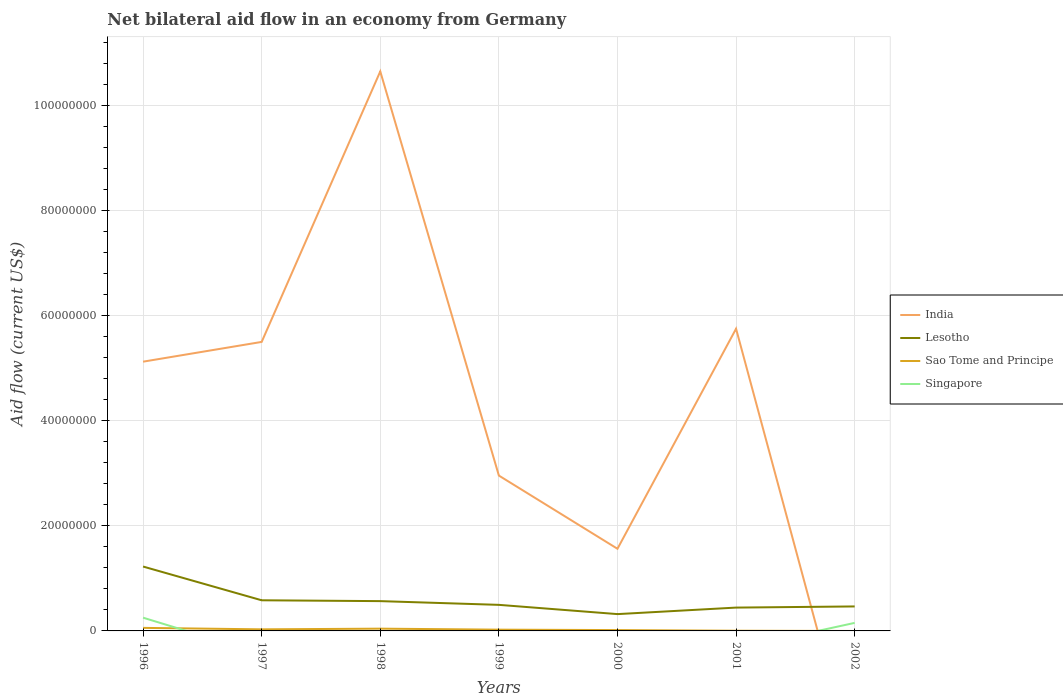Across all years, what is the maximum net bilateral aid flow in Lesotho?
Ensure brevity in your answer.  3.20e+06. What is the difference between the highest and the second highest net bilateral aid flow in Sao Tome and Principe?
Provide a short and direct response. 5.80e+05. Is the net bilateral aid flow in India strictly greater than the net bilateral aid flow in Sao Tome and Principe over the years?
Give a very brief answer. No. How many lines are there?
Offer a very short reply. 4. How many years are there in the graph?
Offer a very short reply. 7. Are the values on the major ticks of Y-axis written in scientific E-notation?
Give a very brief answer. No. Does the graph contain any zero values?
Give a very brief answer. Yes. Does the graph contain grids?
Your response must be concise. Yes. How many legend labels are there?
Offer a terse response. 4. What is the title of the graph?
Offer a terse response. Net bilateral aid flow in an economy from Germany. Does "Czech Republic" appear as one of the legend labels in the graph?
Provide a short and direct response. No. What is the label or title of the X-axis?
Provide a succinct answer. Years. What is the label or title of the Y-axis?
Ensure brevity in your answer.  Aid flow (current US$). What is the Aid flow (current US$) in India in 1996?
Your response must be concise. 5.12e+07. What is the Aid flow (current US$) in Lesotho in 1996?
Offer a terse response. 1.22e+07. What is the Aid flow (current US$) in Sao Tome and Principe in 1996?
Ensure brevity in your answer.  5.80e+05. What is the Aid flow (current US$) in Singapore in 1996?
Your answer should be compact. 2.52e+06. What is the Aid flow (current US$) of India in 1997?
Make the answer very short. 5.50e+07. What is the Aid flow (current US$) of Lesotho in 1997?
Give a very brief answer. 5.83e+06. What is the Aid flow (current US$) of India in 1998?
Your answer should be very brief. 1.06e+08. What is the Aid flow (current US$) of Lesotho in 1998?
Provide a succinct answer. 5.67e+06. What is the Aid flow (current US$) of Sao Tome and Principe in 1998?
Offer a terse response. 4.30e+05. What is the Aid flow (current US$) in Singapore in 1998?
Your answer should be very brief. 0. What is the Aid flow (current US$) of India in 1999?
Your response must be concise. 2.96e+07. What is the Aid flow (current US$) in Lesotho in 1999?
Your answer should be compact. 4.96e+06. What is the Aid flow (current US$) in Sao Tome and Principe in 1999?
Your answer should be very brief. 2.40e+05. What is the Aid flow (current US$) in Singapore in 1999?
Provide a short and direct response. 0. What is the Aid flow (current US$) of India in 2000?
Your answer should be very brief. 1.56e+07. What is the Aid flow (current US$) in Lesotho in 2000?
Offer a very short reply. 3.20e+06. What is the Aid flow (current US$) of Sao Tome and Principe in 2000?
Offer a very short reply. 1.60e+05. What is the Aid flow (current US$) in Singapore in 2000?
Provide a short and direct response. 0. What is the Aid flow (current US$) of India in 2001?
Offer a terse response. 5.75e+07. What is the Aid flow (current US$) of Lesotho in 2001?
Make the answer very short. 4.44e+06. What is the Aid flow (current US$) in Singapore in 2001?
Offer a very short reply. 0. What is the Aid flow (current US$) in India in 2002?
Make the answer very short. 0. What is the Aid flow (current US$) of Lesotho in 2002?
Offer a terse response. 4.66e+06. What is the Aid flow (current US$) of Singapore in 2002?
Ensure brevity in your answer.  1.53e+06. Across all years, what is the maximum Aid flow (current US$) in India?
Your answer should be compact. 1.06e+08. Across all years, what is the maximum Aid flow (current US$) in Lesotho?
Ensure brevity in your answer.  1.22e+07. Across all years, what is the maximum Aid flow (current US$) of Sao Tome and Principe?
Make the answer very short. 5.80e+05. Across all years, what is the maximum Aid flow (current US$) of Singapore?
Offer a terse response. 2.52e+06. Across all years, what is the minimum Aid flow (current US$) in India?
Provide a short and direct response. 0. Across all years, what is the minimum Aid flow (current US$) of Lesotho?
Provide a short and direct response. 3.20e+06. Across all years, what is the minimum Aid flow (current US$) in Sao Tome and Principe?
Keep it short and to the point. 0. Across all years, what is the minimum Aid flow (current US$) of Singapore?
Keep it short and to the point. 0. What is the total Aid flow (current US$) in India in the graph?
Offer a terse response. 3.15e+08. What is the total Aid flow (current US$) of Lesotho in the graph?
Give a very brief answer. 4.10e+07. What is the total Aid flow (current US$) of Sao Tome and Principe in the graph?
Your answer should be very brief. 1.75e+06. What is the total Aid flow (current US$) of Singapore in the graph?
Keep it short and to the point. 4.05e+06. What is the difference between the Aid flow (current US$) in India in 1996 and that in 1997?
Give a very brief answer. -3.76e+06. What is the difference between the Aid flow (current US$) of Lesotho in 1996 and that in 1997?
Your answer should be compact. 6.42e+06. What is the difference between the Aid flow (current US$) in India in 1996 and that in 1998?
Give a very brief answer. -5.52e+07. What is the difference between the Aid flow (current US$) of Lesotho in 1996 and that in 1998?
Your answer should be compact. 6.58e+06. What is the difference between the Aid flow (current US$) in Sao Tome and Principe in 1996 and that in 1998?
Your response must be concise. 1.50e+05. What is the difference between the Aid flow (current US$) in India in 1996 and that in 1999?
Provide a succinct answer. 2.17e+07. What is the difference between the Aid flow (current US$) of Lesotho in 1996 and that in 1999?
Provide a succinct answer. 7.29e+06. What is the difference between the Aid flow (current US$) in Sao Tome and Principe in 1996 and that in 1999?
Your answer should be compact. 3.40e+05. What is the difference between the Aid flow (current US$) of India in 1996 and that in 2000?
Give a very brief answer. 3.56e+07. What is the difference between the Aid flow (current US$) in Lesotho in 1996 and that in 2000?
Provide a succinct answer. 9.05e+06. What is the difference between the Aid flow (current US$) in India in 1996 and that in 2001?
Ensure brevity in your answer.  -6.27e+06. What is the difference between the Aid flow (current US$) of Lesotho in 1996 and that in 2001?
Your answer should be very brief. 7.81e+06. What is the difference between the Aid flow (current US$) of Sao Tome and Principe in 1996 and that in 2001?
Ensure brevity in your answer.  5.40e+05. What is the difference between the Aid flow (current US$) of Lesotho in 1996 and that in 2002?
Your answer should be compact. 7.59e+06. What is the difference between the Aid flow (current US$) of Singapore in 1996 and that in 2002?
Provide a succinct answer. 9.90e+05. What is the difference between the Aid flow (current US$) of India in 1997 and that in 1998?
Your answer should be very brief. -5.15e+07. What is the difference between the Aid flow (current US$) of Lesotho in 1997 and that in 1998?
Offer a very short reply. 1.60e+05. What is the difference between the Aid flow (current US$) in Sao Tome and Principe in 1997 and that in 1998?
Your response must be concise. -1.30e+05. What is the difference between the Aid flow (current US$) of India in 1997 and that in 1999?
Ensure brevity in your answer.  2.54e+07. What is the difference between the Aid flow (current US$) of Lesotho in 1997 and that in 1999?
Provide a succinct answer. 8.70e+05. What is the difference between the Aid flow (current US$) of India in 1997 and that in 2000?
Your answer should be very brief. 3.94e+07. What is the difference between the Aid flow (current US$) in Lesotho in 1997 and that in 2000?
Make the answer very short. 2.63e+06. What is the difference between the Aid flow (current US$) in India in 1997 and that in 2001?
Your response must be concise. -2.51e+06. What is the difference between the Aid flow (current US$) in Lesotho in 1997 and that in 2001?
Your response must be concise. 1.39e+06. What is the difference between the Aid flow (current US$) in Lesotho in 1997 and that in 2002?
Your answer should be very brief. 1.17e+06. What is the difference between the Aid flow (current US$) in India in 1998 and that in 1999?
Make the answer very short. 7.69e+07. What is the difference between the Aid flow (current US$) of Lesotho in 1998 and that in 1999?
Your answer should be very brief. 7.10e+05. What is the difference between the Aid flow (current US$) in Sao Tome and Principe in 1998 and that in 1999?
Your response must be concise. 1.90e+05. What is the difference between the Aid flow (current US$) in India in 1998 and that in 2000?
Offer a terse response. 9.08e+07. What is the difference between the Aid flow (current US$) in Lesotho in 1998 and that in 2000?
Your answer should be very brief. 2.47e+06. What is the difference between the Aid flow (current US$) of India in 1998 and that in 2001?
Provide a short and direct response. 4.90e+07. What is the difference between the Aid flow (current US$) of Lesotho in 1998 and that in 2001?
Provide a succinct answer. 1.23e+06. What is the difference between the Aid flow (current US$) of Sao Tome and Principe in 1998 and that in 2001?
Offer a very short reply. 3.90e+05. What is the difference between the Aid flow (current US$) in Lesotho in 1998 and that in 2002?
Provide a short and direct response. 1.01e+06. What is the difference between the Aid flow (current US$) in India in 1999 and that in 2000?
Your answer should be very brief. 1.39e+07. What is the difference between the Aid flow (current US$) in Lesotho in 1999 and that in 2000?
Make the answer very short. 1.76e+06. What is the difference between the Aid flow (current US$) of Sao Tome and Principe in 1999 and that in 2000?
Keep it short and to the point. 8.00e+04. What is the difference between the Aid flow (current US$) of India in 1999 and that in 2001?
Ensure brevity in your answer.  -2.79e+07. What is the difference between the Aid flow (current US$) in Lesotho in 1999 and that in 2001?
Provide a succinct answer. 5.20e+05. What is the difference between the Aid flow (current US$) of Lesotho in 1999 and that in 2002?
Your answer should be compact. 3.00e+05. What is the difference between the Aid flow (current US$) of India in 2000 and that in 2001?
Ensure brevity in your answer.  -4.19e+07. What is the difference between the Aid flow (current US$) of Lesotho in 2000 and that in 2001?
Provide a short and direct response. -1.24e+06. What is the difference between the Aid flow (current US$) in Sao Tome and Principe in 2000 and that in 2001?
Offer a terse response. 1.20e+05. What is the difference between the Aid flow (current US$) in Lesotho in 2000 and that in 2002?
Your response must be concise. -1.46e+06. What is the difference between the Aid flow (current US$) of India in 1996 and the Aid flow (current US$) of Lesotho in 1997?
Provide a succinct answer. 4.54e+07. What is the difference between the Aid flow (current US$) of India in 1996 and the Aid flow (current US$) of Sao Tome and Principe in 1997?
Offer a terse response. 5.09e+07. What is the difference between the Aid flow (current US$) of Lesotho in 1996 and the Aid flow (current US$) of Sao Tome and Principe in 1997?
Provide a short and direct response. 1.20e+07. What is the difference between the Aid flow (current US$) in India in 1996 and the Aid flow (current US$) in Lesotho in 1998?
Give a very brief answer. 4.56e+07. What is the difference between the Aid flow (current US$) in India in 1996 and the Aid flow (current US$) in Sao Tome and Principe in 1998?
Keep it short and to the point. 5.08e+07. What is the difference between the Aid flow (current US$) of Lesotho in 1996 and the Aid flow (current US$) of Sao Tome and Principe in 1998?
Make the answer very short. 1.18e+07. What is the difference between the Aid flow (current US$) of India in 1996 and the Aid flow (current US$) of Lesotho in 1999?
Keep it short and to the point. 4.63e+07. What is the difference between the Aid flow (current US$) in India in 1996 and the Aid flow (current US$) in Sao Tome and Principe in 1999?
Offer a very short reply. 5.10e+07. What is the difference between the Aid flow (current US$) of Lesotho in 1996 and the Aid flow (current US$) of Sao Tome and Principe in 1999?
Offer a terse response. 1.20e+07. What is the difference between the Aid flow (current US$) of India in 1996 and the Aid flow (current US$) of Lesotho in 2000?
Provide a short and direct response. 4.80e+07. What is the difference between the Aid flow (current US$) of India in 1996 and the Aid flow (current US$) of Sao Tome and Principe in 2000?
Give a very brief answer. 5.11e+07. What is the difference between the Aid flow (current US$) of Lesotho in 1996 and the Aid flow (current US$) of Sao Tome and Principe in 2000?
Offer a terse response. 1.21e+07. What is the difference between the Aid flow (current US$) of India in 1996 and the Aid flow (current US$) of Lesotho in 2001?
Your answer should be very brief. 4.68e+07. What is the difference between the Aid flow (current US$) of India in 1996 and the Aid flow (current US$) of Sao Tome and Principe in 2001?
Your response must be concise. 5.12e+07. What is the difference between the Aid flow (current US$) of Lesotho in 1996 and the Aid flow (current US$) of Sao Tome and Principe in 2001?
Offer a very short reply. 1.22e+07. What is the difference between the Aid flow (current US$) of India in 1996 and the Aid flow (current US$) of Lesotho in 2002?
Your answer should be very brief. 4.66e+07. What is the difference between the Aid flow (current US$) of India in 1996 and the Aid flow (current US$) of Singapore in 2002?
Offer a terse response. 4.97e+07. What is the difference between the Aid flow (current US$) of Lesotho in 1996 and the Aid flow (current US$) of Singapore in 2002?
Offer a terse response. 1.07e+07. What is the difference between the Aid flow (current US$) in Sao Tome and Principe in 1996 and the Aid flow (current US$) in Singapore in 2002?
Your response must be concise. -9.50e+05. What is the difference between the Aid flow (current US$) in India in 1997 and the Aid flow (current US$) in Lesotho in 1998?
Ensure brevity in your answer.  4.93e+07. What is the difference between the Aid flow (current US$) of India in 1997 and the Aid flow (current US$) of Sao Tome and Principe in 1998?
Provide a succinct answer. 5.46e+07. What is the difference between the Aid flow (current US$) in Lesotho in 1997 and the Aid flow (current US$) in Sao Tome and Principe in 1998?
Keep it short and to the point. 5.40e+06. What is the difference between the Aid flow (current US$) of India in 1997 and the Aid flow (current US$) of Lesotho in 1999?
Provide a succinct answer. 5.00e+07. What is the difference between the Aid flow (current US$) of India in 1997 and the Aid flow (current US$) of Sao Tome and Principe in 1999?
Give a very brief answer. 5.48e+07. What is the difference between the Aid flow (current US$) in Lesotho in 1997 and the Aid flow (current US$) in Sao Tome and Principe in 1999?
Offer a very short reply. 5.59e+06. What is the difference between the Aid flow (current US$) of India in 1997 and the Aid flow (current US$) of Lesotho in 2000?
Keep it short and to the point. 5.18e+07. What is the difference between the Aid flow (current US$) of India in 1997 and the Aid flow (current US$) of Sao Tome and Principe in 2000?
Offer a very short reply. 5.48e+07. What is the difference between the Aid flow (current US$) in Lesotho in 1997 and the Aid flow (current US$) in Sao Tome and Principe in 2000?
Your answer should be compact. 5.67e+06. What is the difference between the Aid flow (current US$) of India in 1997 and the Aid flow (current US$) of Lesotho in 2001?
Provide a succinct answer. 5.06e+07. What is the difference between the Aid flow (current US$) in India in 1997 and the Aid flow (current US$) in Sao Tome and Principe in 2001?
Provide a succinct answer. 5.50e+07. What is the difference between the Aid flow (current US$) of Lesotho in 1997 and the Aid flow (current US$) of Sao Tome and Principe in 2001?
Keep it short and to the point. 5.79e+06. What is the difference between the Aid flow (current US$) in India in 1997 and the Aid flow (current US$) in Lesotho in 2002?
Offer a terse response. 5.03e+07. What is the difference between the Aid flow (current US$) in India in 1997 and the Aid flow (current US$) in Singapore in 2002?
Ensure brevity in your answer.  5.35e+07. What is the difference between the Aid flow (current US$) in Lesotho in 1997 and the Aid flow (current US$) in Singapore in 2002?
Give a very brief answer. 4.30e+06. What is the difference between the Aid flow (current US$) of Sao Tome and Principe in 1997 and the Aid flow (current US$) of Singapore in 2002?
Keep it short and to the point. -1.23e+06. What is the difference between the Aid flow (current US$) in India in 1998 and the Aid flow (current US$) in Lesotho in 1999?
Your response must be concise. 1.02e+08. What is the difference between the Aid flow (current US$) in India in 1998 and the Aid flow (current US$) in Sao Tome and Principe in 1999?
Ensure brevity in your answer.  1.06e+08. What is the difference between the Aid flow (current US$) in Lesotho in 1998 and the Aid flow (current US$) in Sao Tome and Principe in 1999?
Your answer should be very brief. 5.43e+06. What is the difference between the Aid flow (current US$) in India in 1998 and the Aid flow (current US$) in Lesotho in 2000?
Your response must be concise. 1.03e+08. What is the difference between the Aid flow (current US$) in India in 1998 and the Aid flow (current US$) in Sao Tome and Principe in 2000?
Ensure brevity in your answer.  1.06e+08. What is the difference between the Aid flow (current US$) of Lesotho in 1998 and the Aid flow (current US$) of Sao Tome and Principe in 2000?
Give a very brief answer. 5.51e+06. What is the difference between the Aid flow (current US$) in India in 1998 and the Aid flow (current US$) in Lesotho in 2001?
Your response must be concise. 1.02e+08. What is the difference between the Aid flow (current US$) in India in 1998 and the Aid flow (current US$) in Sao Tome and Principe in 2001?
Your answer should be very brief. 1.06e+08. What is the difference between the Aid flow (current US$) of Lesotho in 1998 and the Aid flow (current US$) of Sao Tome and Principe in 2001?
Your answer should be very brief. 5.63e+06. What is the difference between the Aid flow (current US$) in India in 1998 and the Aid flow (current US$) in Lesotho in 2002?
Offer a terse response. 1.02e+08. What is the difference between the Aid flow (current US$) of India in 1998 and the Aid flow (current US$) of Singapore in 2002?
Ensure brevity in your answer.  1.05e+08. What is the difference between the Aid flow (current US$) in Lesotho in 1998 and the Aid flow (current US$) in Singapore in 2002?
Ensure brevity in your answer.  4.14e+06. What is the difference between the Aid flow (current US$) in Sao Tome and Principe in 1998 and the Aid flow (current US$) in Singapore in 2002?
Provide a short and direct response. -1.10e+06. What is the difference between the Aid flow (current US$) of India in 1999 and the Aid flow (current US$) of Lesotho in 2000?
Provide a succinct answer. 2.64e+07. What is the difference between the Aid flow (current US$) in India in 1999 and the Aid flow (current US$) in Sao Tome and Principe in 2000?
Your response must be concise. 2.94e+07. What is the difference between the Aid flow (current US$) of Lesotho in 1999 and the Aid flow (current US$) of Sao Tome and Principe in 2000?
Offer a terse response. 4.80e+06. What is the difference between the Aid flow (current US$) in India in 1999 and the Aid flow (current US$) in Lesotho in 2001?
Offer a very short reply. 2.51e+07. What is the difference between the Aid flow (current US$) of India in 1999 and the Aid flow (current US$) of Sao Tome and Principe in 2001?
Give a very brief answer. 2.95e+07. What is the difference between the Aid flow (current US$) in Lesotho in 1999 and the Aid flow (current US$) in Sao Tome and Principe in 2001?
Your response must be concise. 4.92e+06. What is the difference between the Aid flow (current US$) of India in 1999 and the Aid flow (current US$) of Lesotho in 2002?
Keep it short and to the point. 2.49e+07. What is the difference between the Aid flow (current US$) in India in 1999 and the Aid flow (current US$) in Singapore in 2002?
Offer a terse response. 2.80e+07. What is the difference between the Aid flow (current US$) in Lesotho in 1999 and the Aid flow (current US$) in Singapore in 2002?
Ensure brevity in your answer.  3.43e+06. What is the difference between the Aid flow (current US$) of Sao Tome and Principe in 1999 and the Aid flow (current US$) of Singapore in 2002?
Your answer should be compact. -1.29e+06. What is the difference between the Aid flow (current US$) of India in 2000 and the Aid flow (current US$) of Lesotho in 2001?
Give a very brief answer. 1.12e+07. What is the difference between the Aid flow (current US$) in India in 2000 and the Aid flow (current US$) in Sao Tome and Principe in 2001?
Keep it short and to the point. 1.56e+07. What is the difference between the Aid flow (current US$) in Lesotho in 2000 and the Aid flow (current US$) in Sao Tome and Principe in 2001?
Give a very brief answer. 3.16e+06. What is the difference between the Aid flow (current US$) of India in 2000 and the Aid flow (current US$) of Lesotho in 2002?
Provide a short and direct response. 1.10e+07. What is the difference between the Aid flow (current US$) in India in 2000 and the Aid flow (current US$) in Singapore in 2002?
Provide a short and direct response. 1.41e+07. What is the difference between the Aid flow (current US$) in Lesotho in 2000 and the Aid flow (current US$) in Singapore in 2002?
Offer a very short reply. 1.67e+06. What is the difference between the Aid flow (current US$) of Sao Tome and Principe in 2000 and the Aid flow (current US$) of Singapore in 2002?
Your response must be concise. -1.37e+06. What is the difference between the Aid flow (current US$) of India in 2001 and the Aid flow (current US$) of Lesotho in 2002?
Ensure brevity in your answer.  5.28e+07. What is the difference between the Aid flow (current US$) in India in 2001 and the Aid flow (current US$) in Singapore in 2002?
Ensure brevity in your answer.  5.60e+07. What is the difference between the Aid flow (current US$) in Lesotho in 2001 and the Aid flow (current US$) in Singapore in 2002?
Ensure brevity in your answer.  2.91e+06. What is the difference between the Aid flow (current US$) of Sao Tome and Principe in 2001 and the Aid flow (current US$) of Singapore in 2002?
Provide a succinct answer. -1.49e+06. What is the average Aid flow (current US$) in India per year?
Offer a terse response. 4.51e+07. What is the average Aid flow (current US$) in Lesotho per year?
Ensure brevity in your answer.  5.86e+06. What is the average Aid flow (current US$) in Sao Tome and Principe per year?
Provide a succinct answer. 2.50e+05. What is the average Aid flow (current US$) of Singapore per year?
Keep it short and to the point. 5.79e+05. In the year 1996, what is the difference between the Aid flow (current US$) in India and Aid flow (current US$) in Lesotho?
Provide a short and direct response. 3.90e+07. In the year 1996, what is the difference between the Aid flow (current US$) in India and Aid flow (current US$) in Sao Tome and Principe?
Offer a terse response. 5.06e+07. In the year 1996, what is the difference between the Aid flow (current US$) of India and Aid flow (current US$) of Singapore?
Make the answer very short. 4.87e+07. In the year 1996, what is the difference between the Aid flow (current US$) of Lesotho and Aid flow (current US$) of Sao Tome and Principe?
Your answer should be compact. 1.17e+07. In the year 1996, what is the difference between the Aid flow (current US$) in Lesotho and Aid flow (current US$) in Singapore?
Ensure brevity in your answer.  9.73e+06. In the year 1996, what is the difference between the Aid flow (current US$) of Sao Tome and Principe and Aid flow (current US$) of Singapore?
Give a very brief answer. -1.94e+06. In the year 1997, what is the difference between the Aid flow (current US$) of India and Aid flow (current US$) of Lesotho?
Ensure brevity in your answer.  4.92e+07. In the year 1997, what is the difference between the Aid flow (current US$) of India and Aid flow (current US$) of Sao Tome and Principe?
Give a very brief answer. 5.47e+07. In the year 1997, what is the difference between the Aid flow (current US$) of Lesotho and Aid flow (current US$) of Sao Tome and Principe?
Offer a very short reply. 5.53e+06. In the year 1998, what is the difference between the Aid flow (current US$) of India and Aid flow (current US$) of Lesotho?
Offer a terse response. 1.01e+08. In the year 1998, what is the difference between the Aid flow (current US$) in India and Aid flow (current US$) in Sao Tome and Principe?
Offer a very short reply. 1.06e+08. In the year 1998, what is the difference between the Aid flow (current US$) in Lesotho and Aid flow (current US$) in Sao Tome and Principe?
Ensure brevity in your answer.  5.24e+06. In the year 1999, what is the difference between the Aid flow (current US$) in India and Aid flow (current US$) in Lesotho?
Provide a succinct answer. 2.46e+07. In the year 1999, what is the difference between the Aid flow (current US$) in India and Aid flow (current US$) in Sao Tome and Principe?
Your response must be concise. 2.93e+07. In the year 1999, what is the difference between the Aid flow (current US$) in Lesotho and Aid flow (current US$) in Sao Tome and Principe?
Give a very brief answer. 4.72e+06. In the year 2000, what is the difference between the Aid flow (current US$) in India and Aid flow (current US$) in Lesotho?
Make the answer very short. 1.24e+07. In the year 2000, what is the difference between the Aid flow (current US$) of India and Aid flow (current US$) of Sao Tome and Principe?
Your response must be concise. 1.55e+07. In the year 2000, what is the difference between the Aid flow (current US$) in Lesotho and Aid flow (current US$) in Sao Tome and Principe?
Provide a short and direct response. 3.04e+06. In the year 2001, what is the difference between the Aid flow (current US$) of India and Aid flow (current US$) of Lesotho?
Give a very brief answer. 5.31e+07. In the year 2001, what is the difference between the Aid flow (current US$) in India and Aid flow (current US$) in Sao Tome and Principe?
Offer a terse response. 5.75e+07. In the year 2001, what is the difference between the Aid flow (current US$) in Lesotho and Aid flow (current US$) in Sao Tome and Principe?
Ensure brevity in your answer.  4.40e+06. In the year 2002, what is the difference between the Aid flow (current US$) of Lesotho and Aid flow (current US$) of Singapore?
Keep it short and to the point. 3.13e+06. What is the ratio of the Aid flow (current US$) of India in 1996 to that in 1997?
Offer a terse response. 0.93. What is the ratio of the Aid flow (current US$) in Lesotho in 1996 to that in 1997?
Provide a short and direct response. 2.1. What is the ratio of the Aid flow (current US$) of Sao Tome and Principe in 1996 to that in 1997?
Ensure brevity in your answer.  1.93. What is the ratio of the Aid flow (current US$) of India in 1996 to that in 1998?
Your response must be concise. 0.48. What is the ratio of the Aid flow (current US$) of Lesotho in 1996 to that in 1998?
Offer a terse response. 2.16. What is the ratio of the Aid flow (current US$) in Sao Tome and Principe in 1996 to that in 1998?
Offer a terse response. 1.35. What is the ratio of the Aid flow (current US$) of India in 1996 to that in 1999?
Provide a short and direct response. 1.73. What is the ratio of the Aid flow (current US$) of Lesotho in 1996 to that in 1999?
Your answer should be compact. 2.47. What is the ratio of the Aid flow (current US$) in Sao Tome and Principe in 1996 to that in 1999?
Keep it short and to the point. 2.42. What is the ratio of the Aid flow (current US$) of India in 1996 to that in 2000?
Ensure brevity in your answer.  3.28. What is the ratio of the Aid flow (current US$) in Lesotho in 1996 to that in 2000?
Provide a succinct answer. 3.83. What is the ratio of the Aid flow (current US$) of Sao Tome and Principe in 1996 to that in 2000?
Provide a succinct answer. 3.62. What is the ratio of the Aid flow (current US$) of India in 1996 to that in 2001?
Offer a very short reply. 0.89. What is the ratio of the Aid flow (current US$) in Lesotho in 1996 to that in 2001?
Make the answer very short. 2.76. What is the ratio of the Aid flow (current US$) of Sao Tome and Principe in 1996 to that in 2001?
Ensure brevity in your answer.  14.5. What is the ratio of the Aid flow (current US$) of Lesotho in 1996 to that in 2002?
Your answer should be very brief. 2.63. What is the ratio of the Aid flow (current US$) in Singapore in 1996 to that in 2002?
Your response must be concise. 1.65. What is the ratio of the Aid flow (current US$) of India in 1997 to that in 1998?
Offer a terse response. 0.52. What is the ratio of the Aid flow (current US$) in Lesotho in 1997 to that in 1998?
Offer a very short reply. 1.03. What is the ratio of the Aid flow (current US$) of Sao Tome and Principe in 1997 to that in 1998?
Offer a terse response. 0.7. What is the ratio of the Aid flow (current US$) in India in 1997 to that in 1999?
Ensure brevity in your answer.  1.86. What is the ratio of the Aid flow (current US$) in Lesotho in 1997 to that in 1999?
Ensure brevity in your answer.  1.18. What is the ratio of the Aid flow (current US$) of Sao Tome and Principe in 1997 to that in 1999?
Provide a short and direct response. 1.25. What is the ratio of the Aid flow (current US$) of India in 1997 to that in 2000?
Provide a short and direct response. 3.52. What is the ratio of the Aid flow (current US$) of Lesotho in 1997 to that in 2000?
Your answer should be compact. 1.82. What is the ratio of the Aid flow (current US$) in Sao Tome and Principe in 1997 to that in 2000?
Provide a short and direct response. 1.88. What is the ratio of the Aid flow (current US$) in India in 1997 to that in 2001?
Provide a succinct answer. 0.96. What is the ratio of the Aid flow (current US$) in Lesotho in 1997 to that in 2001?
Your answer should be very brief. 1.31. What is the ratio of the Aid flow (current US$) in Sao Tome and Principe in 1997 to that in 2001?
Ensure brevity in your answer.  7.5. What is the ratio of the Aid flow (current US$) of Lesotho in 1997 to that in 2002?
Provide a short and direct response. 1.25. What is the ratio of the Aid flow (current US$) of India in 1998 to that in 1999?
Offer a terse response. 3.6. What is the ratio of the Aid flow (current US$) of Lesotho in 1998 to that in 1999?
Keep it short and to the point. 1.14. What is the ratio of the Aid flow (current US$) of Sao Tome and Principe in 1998 to that in 1999?
Provide a short and direct response. 1.79. What is the ratio of the Aid flow (current US$) in India in 1998 to that in 2000?
Provide a succinct answer. 6.81. What is the ratio of the Aid flow (current US$) in Lesotho in 1998 to that in 2000?
Offer a terse response. 1.77. What is the ratio of the Aid flow (current US$) of Sao Tome and Principe in 1998 to that in 2000?
Give a very brief answer. 2.69. What is the ratio of the Aid flow (current US$) of India in 1998 to that in 2001?
Offer a very short reply. 1.85. What is the ratio of the Aid flow (current US$) of Lesotho in 1998 to that in 2001?
Provide a short and direct response. 1.28. What is the ratio of the Aid flow (current US$) of Sao Tome and Principe in 1998 to that in 2001?
Provide a succinct answer. 10.75. What is the ratio of the Aid flow (current US$) of Lesotho in 1998 to that in 2002?
Offer a terse response. 1.22. What is the ratio of the Aid flow (current US$) in India in 1999 to that in 2000?
Your answer should be very brief. 1.89. What is the ratio of the Aid flow (current US$) in Lesotho in 1999 to that in 2000?
Offer a terse response. 1.55. What is the ratio of the Aid flow (current US$) of India in 1999 to that in 2001?
Your response must be concise. 0.51. What is the ratio of the Aid flow (current US$) of Lesotho in 1999 to that in 2001?
Your answer should be compact. 1.12. What is the ratio of the Aid flow (current US$) of Sao Tome and Principe in 1999 to that in 2001?
Your answer should be compact. 6. What is the ratio of the Aid flow (current US$) of Lesotho in 1999 to that in 2002?
Keep it short and to the point. 1.06. What is the ratio of the Aid flow (current US$) of India in 2000 to that in 2001?
Offer a very short reply. 0.27. What is the ratio of the Aid flow (current US$) in Lesotho in 2000 to that in 2001?
Your answer should be very brief. 0.72. What is the ratio of the Aid flow (current US$) of Lesotho in 2000 to that in 2002?
Give a very brief answer. 0.69. What is the ratio of the Aid flow (current US$) in Lesotho in 2001 to that in 2002?
Offer a terse response. 0.95. What is the difference between the highest and the second highest Aid flow (current US$) of India?
Your answer should be compact. 4.90e+07. What is the difference between the highest and the second highest Aid flow (current US$) of Lesotho?
Your response must be concise. 6.42e+06. What is the difference between the highest and the second highest Aid flow (current US$) in Sao Tome and Principe?
Provide a succinct answer. 1.50e+05. What is the difference between the highest and the lowest Aid flow (current US$) of India?
Your response must be concise. 1.06e+08. What is the difference between the highest and the lowest Aid flow (current US$) in Lesotho?
Provide a succinct answer. 9.05e+06. What is the difference between the highest and the lowest Aid flow (current US$) in Sao Tome and Principe?
Ensure brevity in your answer.  5.80e+05. What is the difference between the highest and the lowest Aid flow (current US$) in Singapore?
Give a very brief answer. 2.52e+06. 